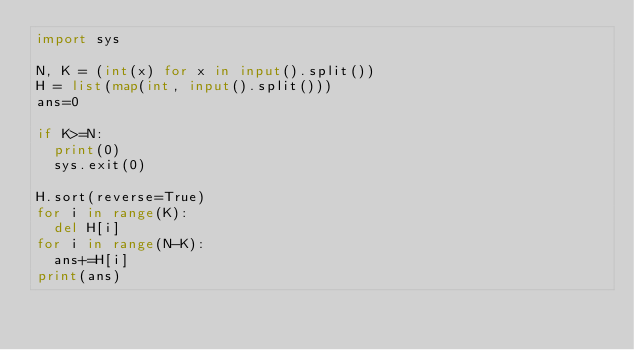<code> <loc_0><loc_0><loc_500><loc_500><_Python_>import sys

N, K = (int(x) for x in input().split())
H = list(map(int, input().split()))
ans=0

if K>=N:
  print(0)
  sys.exit(0)
  
H.sort(reverse=True)
for i in range(K):
  del H[i]
for i in range(N-K):
  ans+=H[i]
print(ans)</code> 